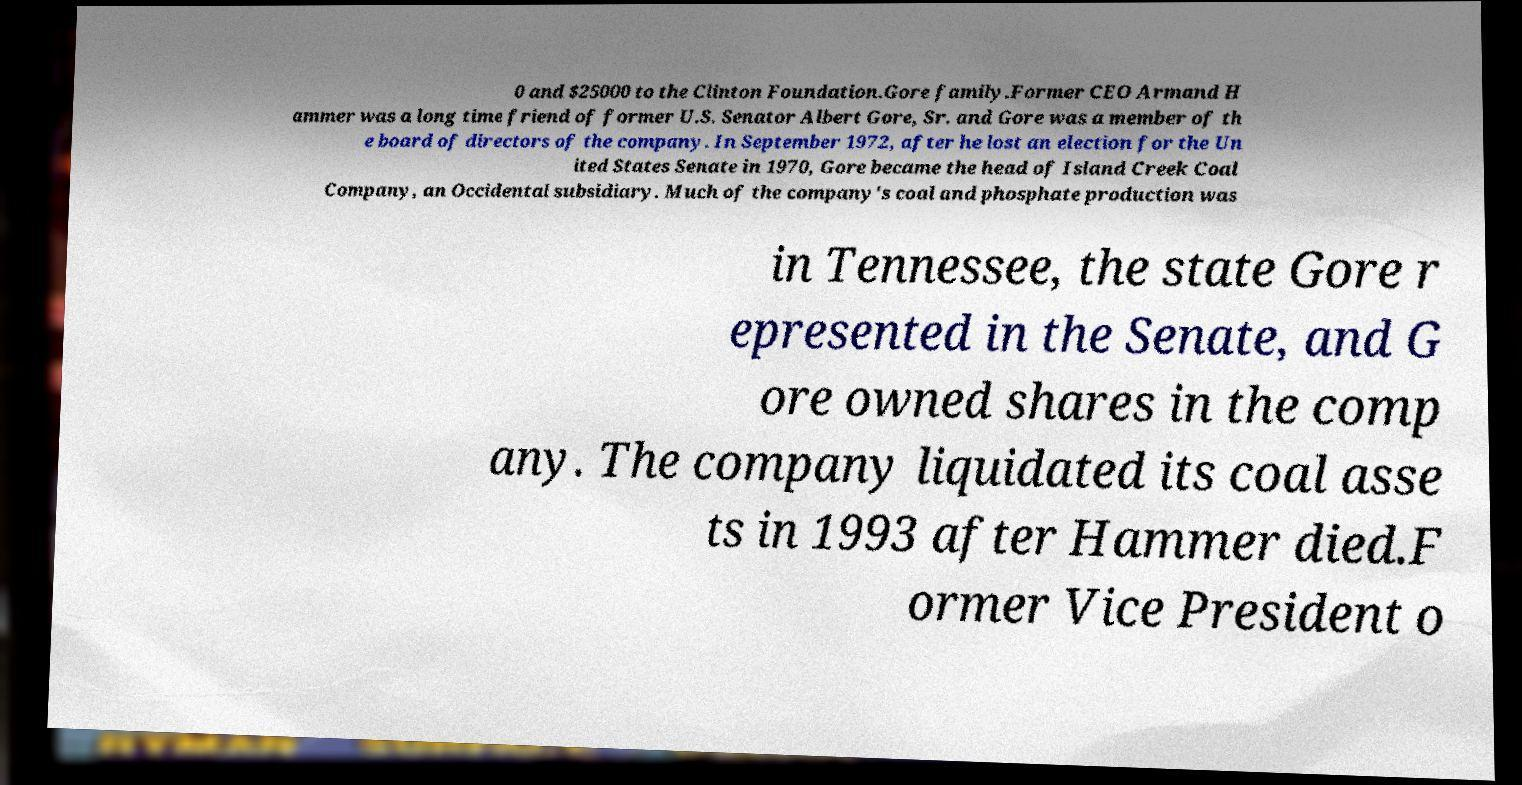Could you extract and type out the text from this image? 0 and $25000 to the Clinton Foundation.Gore family.Former CEO Armand H ammer was a long time friend of former U.S. Senator Albert Gore, Sr. and Gore was a member of th e board of directors of the company. In September 1972, after he lost an election for the Un ited States Senate in 1970, Gore became the head of Island Creek Coal Company, an Occidental subsidiary. Much of the company's coal and phosphate production was in Tennessee, the state Gore r epresented in the Senate, and G ore owned shares in the comp any. The company liquidated its coal asse ts in 1993 after Hammer died.F ormer Vice President o 